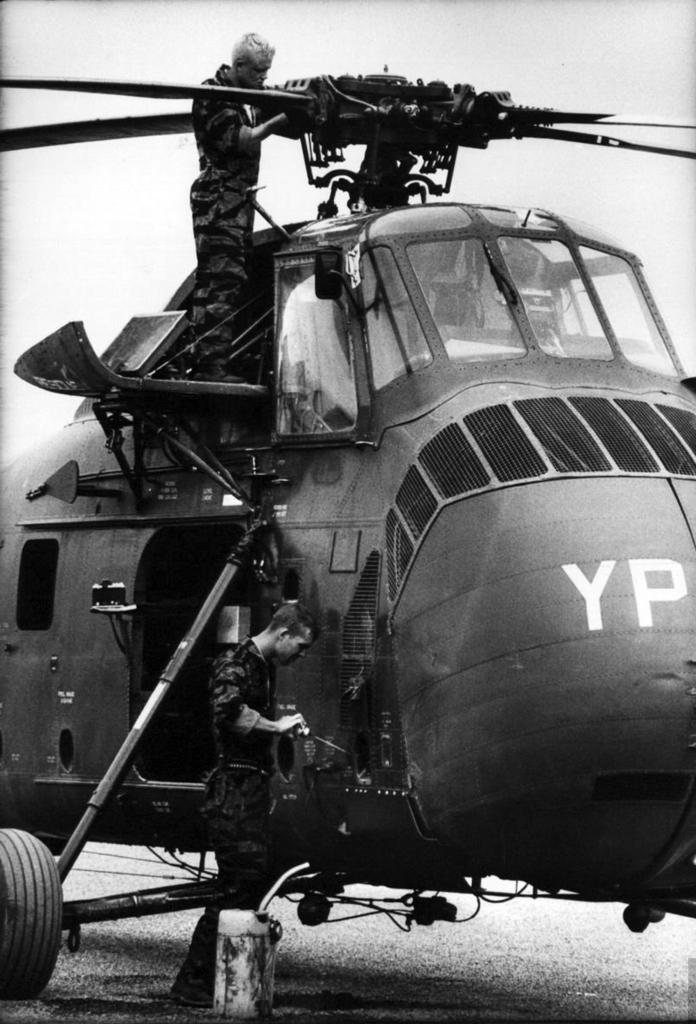<image>
Describe the image concisely. The military helicopter being maintained by two service personnel was marked with the letters 'YP'. 